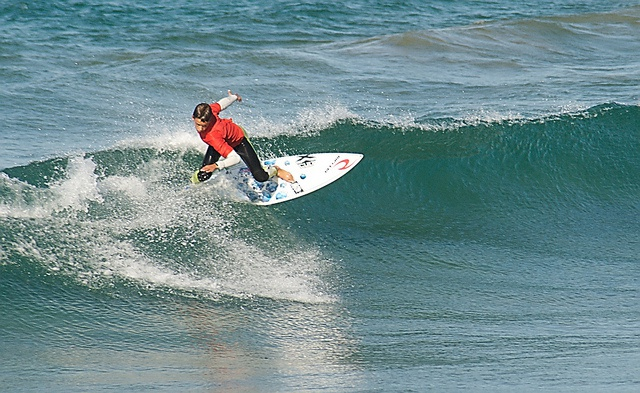Describe the objects in this image and their specific colors. I can see surfboard in teal, white, darkgray, and gray tones and people in teal, black, lightgray, salmon, and maroon tones in this image. 